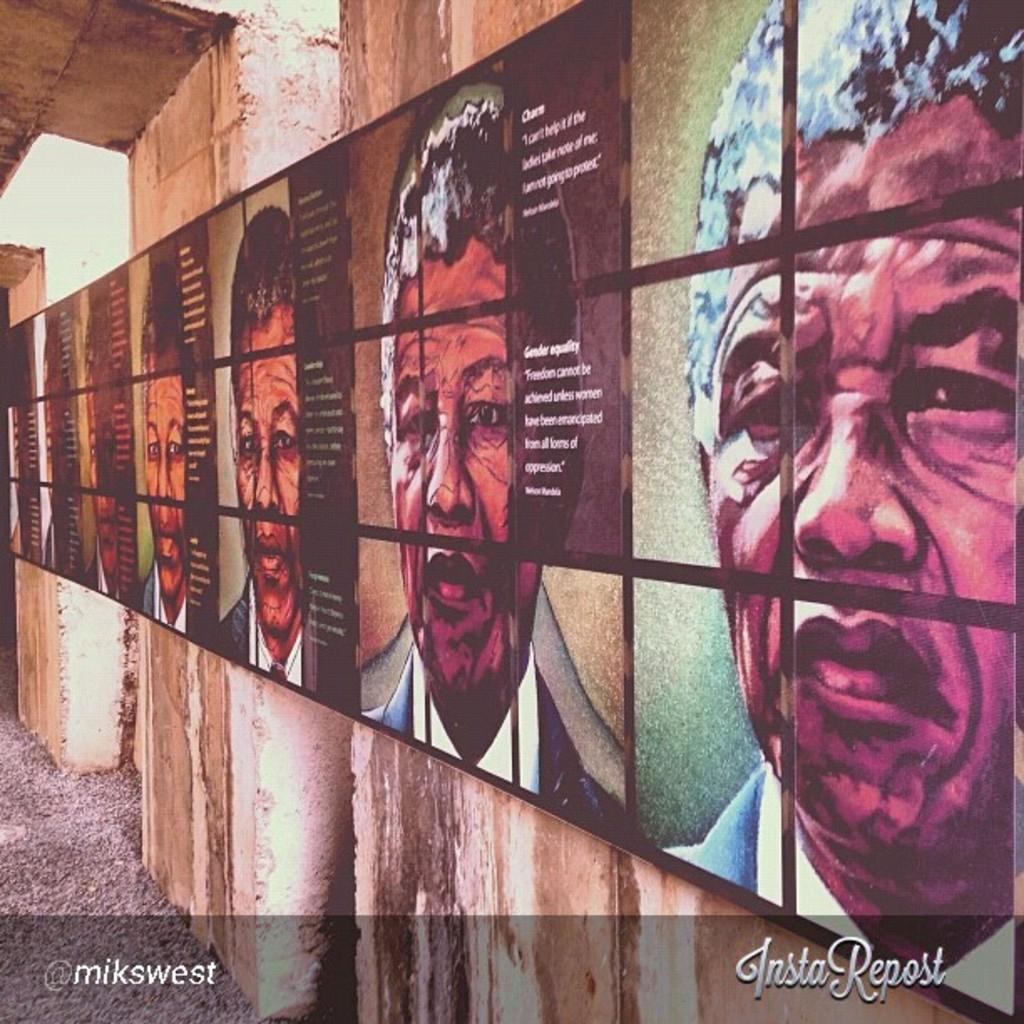What type of images are present in the image? There are pictures of people in the image. Can you describe any other objects or features in the image? Yes, there is an information board attached to the walls in the image. What type of mint can be seen growing near the information board in the image? There is no mint present in the image; it only features pictures of people and an information board. How many dust particles can be seen on the pictures of people in the image? There is no mention of dust particles in the image, and it is not possible to determine their presence or quantity. 